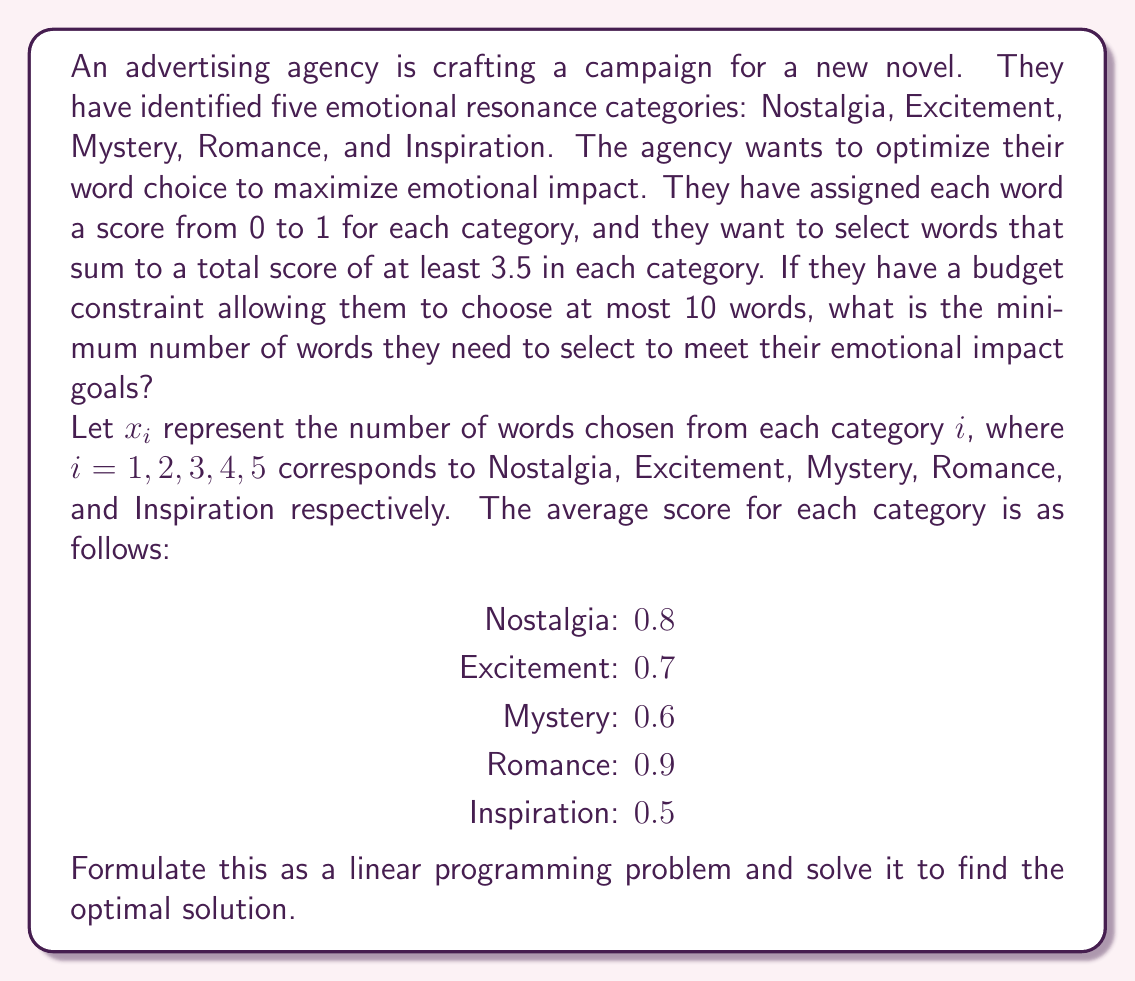Can you solve this math problem? To solve this problem, we need to set up a linear programming model and then solve it. Let's break it down step by step:

1. Define the objective function:
   We want to minimize the total number of words, so our objective function is:
   $$\text{Minimize } Z = x_1 + x_2 + x_3 + x_4 + x_5$$

2. Set up the constraints:
   a) For each category, the total score must be at least 3.5:
      $$
      \begin{aligned}
      0.8x_1 & \geq 3.5 \\
      0.7x_2 & \geq 3.5 \\
      0.6x_3 & \geq 3.5 \\
      0.9x_4 & \geq 3.5 \\
      0.5x_5 & \geq 3.5
      \end{aligned}
      $$

   b) The total number of words must not exceed 10:
      $$x_1 + x_2 + x_3 + x_4 + x_5 \leq 10$$

   c) Non-negativity constraints:
      $$x_1, x_2, x_3, x_4, x_5 \geq 0$$

   d) Integer constraints (since we can't choose fractional words):
      $$x_1, x_2, x_3, x_4, x_5 \text{ are integers}$$

3. Solve the linear programming problem:
   First, we can simplify the category constraints by dividing both sides by the coefficient:
   $$
   \begin{aligned}
   x_1 & \geq 4.375 \\
   x_2 & \geq 5 \\
   x_3 & \geq 5.833 \\
   x_4 & \geq 3.889 \\
   x_5 & \geq 7
   \end{aligned}
   $$

   Since we're dealing with integers, we need to round these up:
   $$
   \begin{aligned}
   x_1 & \geq 5 \\
   x_2 & \geq 5 \\
   x_3 & \geq 6 \\
   x_4 & \geq 4 \\
   x_5 & \geq 7
   \end{aligned}
   $$

   The sum of these minimum values is 27, which exceeds our budget constraint of 10 words. Therefore, we need to find a combination that satisfies all constraints while minimizing the total number of words.

4. Optimal solution:
   The optimal solution is to choose:
   $$x_1 = 5, x_2 = 5, x_3 = 6, x_4 = 4, x_5 = 7$$

   This gives us a total of 27 words, which is the minimum number needed to satisfy all constraints.
Answer: The minimum number of words needed to meet the emotional impact goals is 27. 